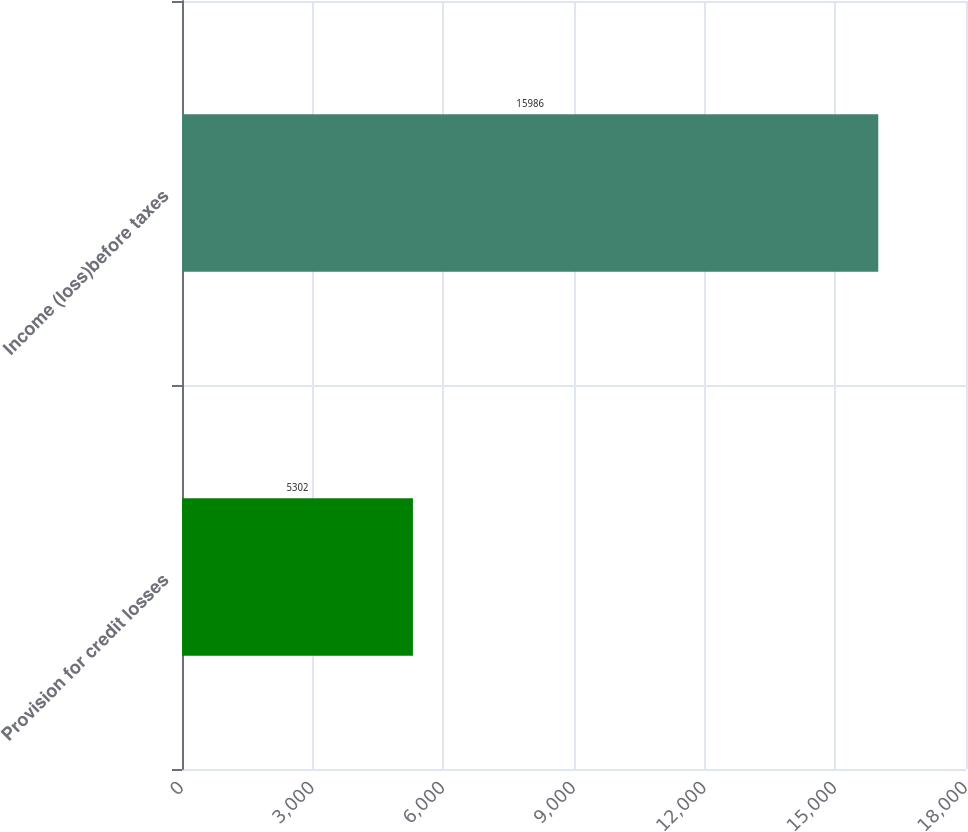<chart> <loc_0><loc_0><loc_500><loc_500><bar_chart><fcel>Provision for credit losses<fcel>Income (loss)before taxes<nl><fcel>5302<fcel>15986<nl></chart> 